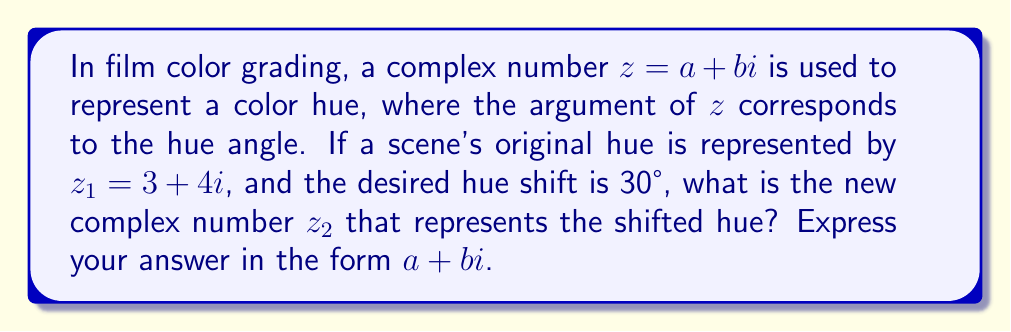Can you answer this question? 1. First, let's calculate the argument of $z_1$:
   $$\arg(z_1) = \tan^{-1}\left(\frac{4}{3}\right) \approx 53.13°$$

2. The new argument after the 30° shift will be:
   $$\arg(z_2) = 53.13° + 30° = 83.13°$$

3. To maintain the same intensity, we want to keep the magnitude of $z_2$ the same as $z_1$. The magnitude of $z_1$ is:
   $$|z_1| = \sqrt{3^2 + 4^2} = 5$$

4. Now, we can express $z_2$ in polar form:
   $$z_2 = 5(\cos(83.13°) + i\sin(83.13°))$$

5. Converting back to rectangular form:
   $$z_2 = 5\cos(83.13°) + 5i\sin(83.13°)$$

6. Calculating the real and imaginary parts:
   $$\begin{align}
   a &= 5\cos(83.13°) \approx 0.6
   b &= 5\sin(83.13°) \approx 4.96
   \end{align}$$

7. Therefore, the new complex number representing the shifted hue is approximately:
   $$z_2 \approx 0.6 + 4.96i$$
Answer: $0.6 + 4.96i$ 